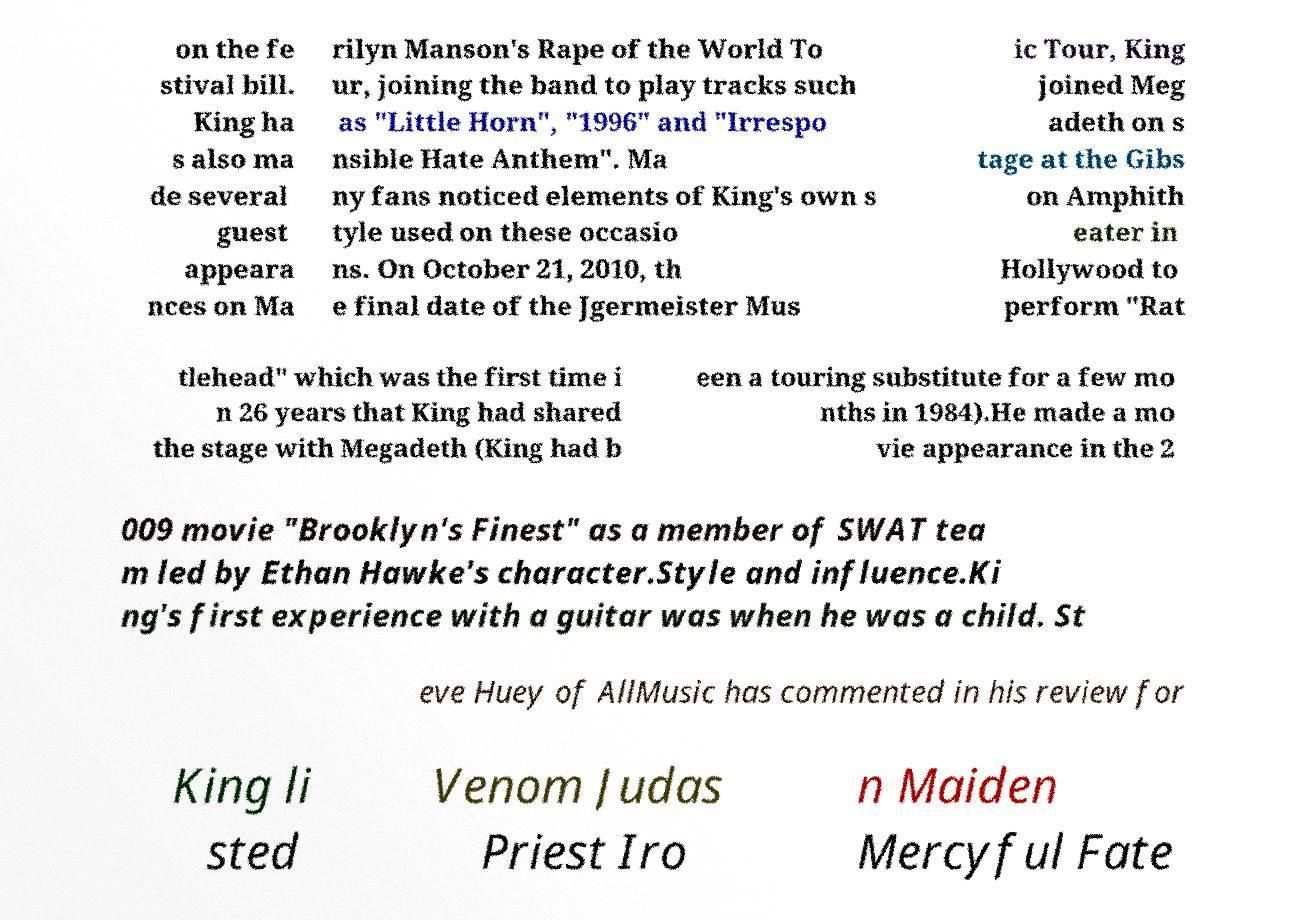Could you assist in decoding the text presented in this image and type it out clearly? on the fe stival bill. King ha s also ma de several guest appeara nces on Ma rilyn Manson's Rape of the World To ur, joining the band to play tracks such as "Little Horn", "1996" and "Irrespo nsible Hate Anthem". Ma ny fans noticed elements of King's own s tyle used on these occasio ns. On October 21, 2010, th e final date of the Jgermeister Mus ic Tour, King joined Meg adeth on s tage at the Gibs on Amphith eater in Hollywood to perform "Rat tlehead" which was the first time i n 26 years that King had shared the stage with Megadeth (King had b een a touring substitute for a few mo nths in 1984).He made a mo vie appearance in the 2 009 movie "Brooklyn's Finest" as a member of SWAT tea m led by Ethan Hawke's character.Style and influence.Ki ng's first experience with a guitar was when he was a child. St eve Huey of AllMusic has commented in his review for King li sted Venom Judas Priest Iro n Maiden Mercyful Fate 